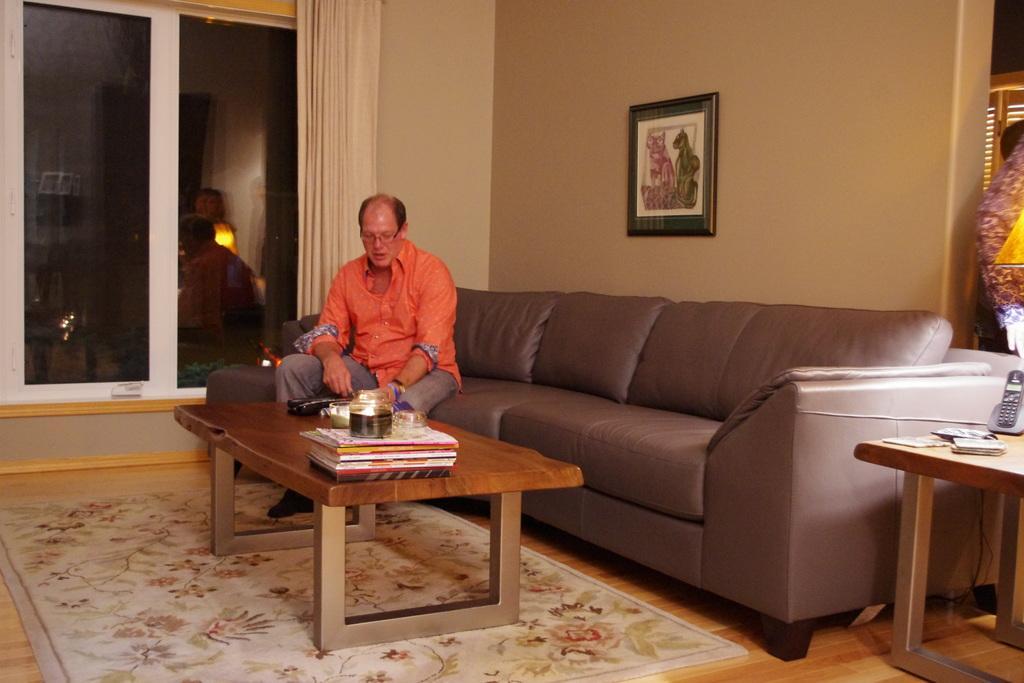How would you summarize this image in a sentence or two? An indoor picture. A man is sitting on a couch. Photo with photo frame. Curtain is in cream color. This is window with glass. Beside this couch there is a table, on a table there is a mobile. In-front of this man there is a table, on this table there are books and jar. Floor with carpet. 